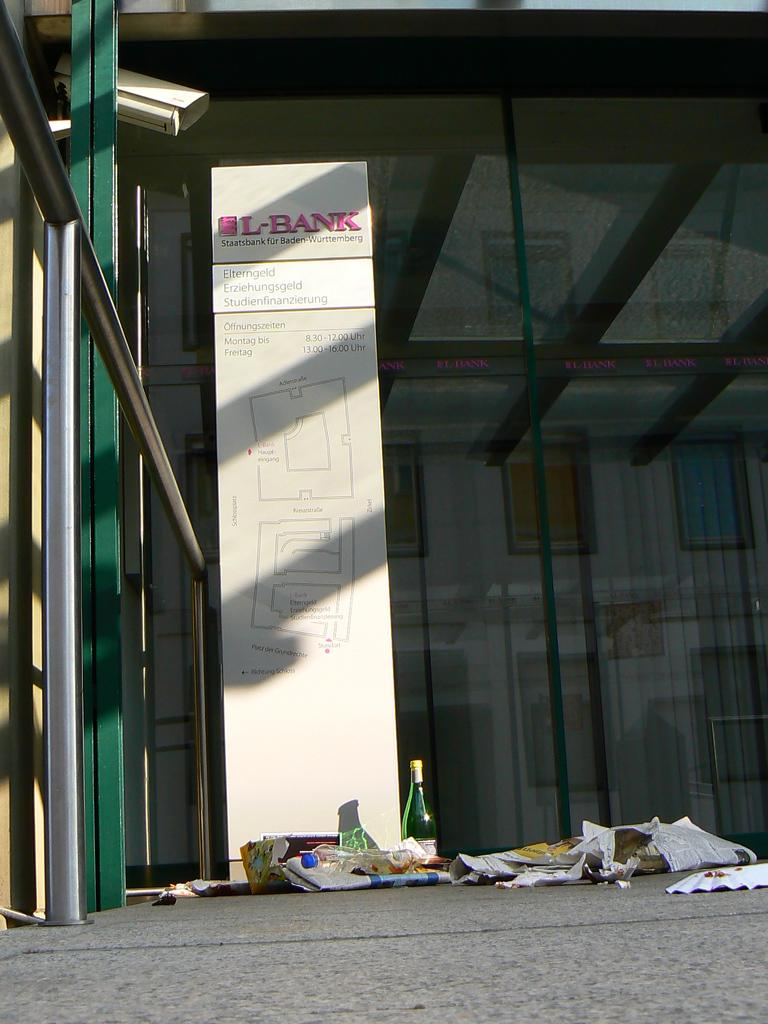What is the main object in the image? There is a board in the image. What information is provided on the board? The board has a title and a location map on it. How many oranges are displayed on the board in the image? There are no oranges displayed on the board in the image. What level of difficulty is indicated on the board? The provided facts do not mention any level of difficulty on the board. 